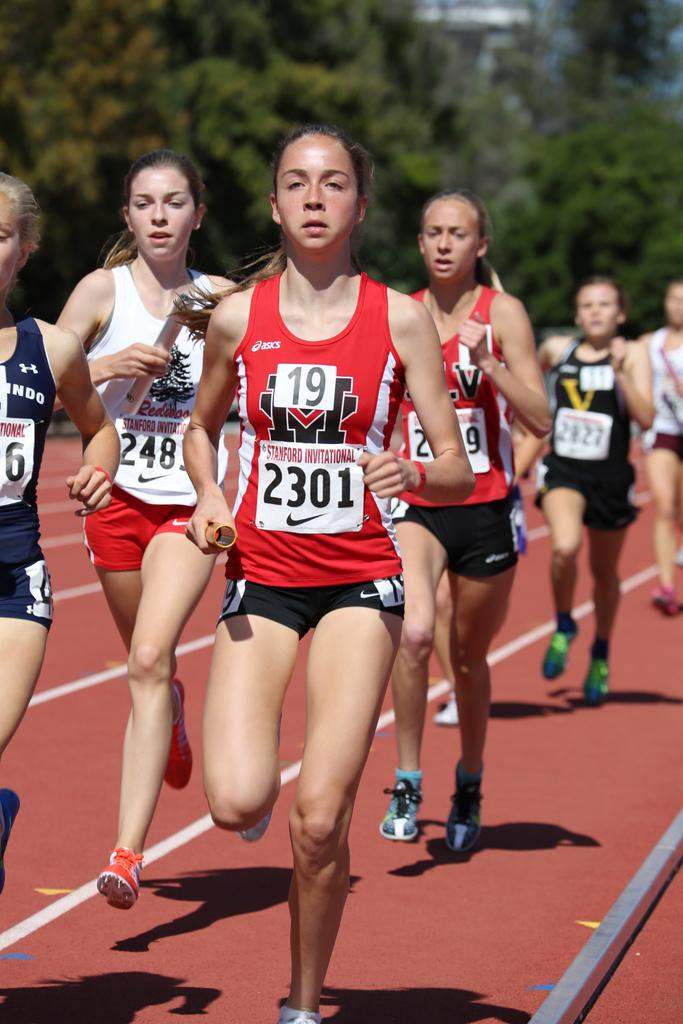<image>
Share a concise interpretation of the image provided. Several track and field numbers for the Women's group taking part in a run, #2301 is out in front. 